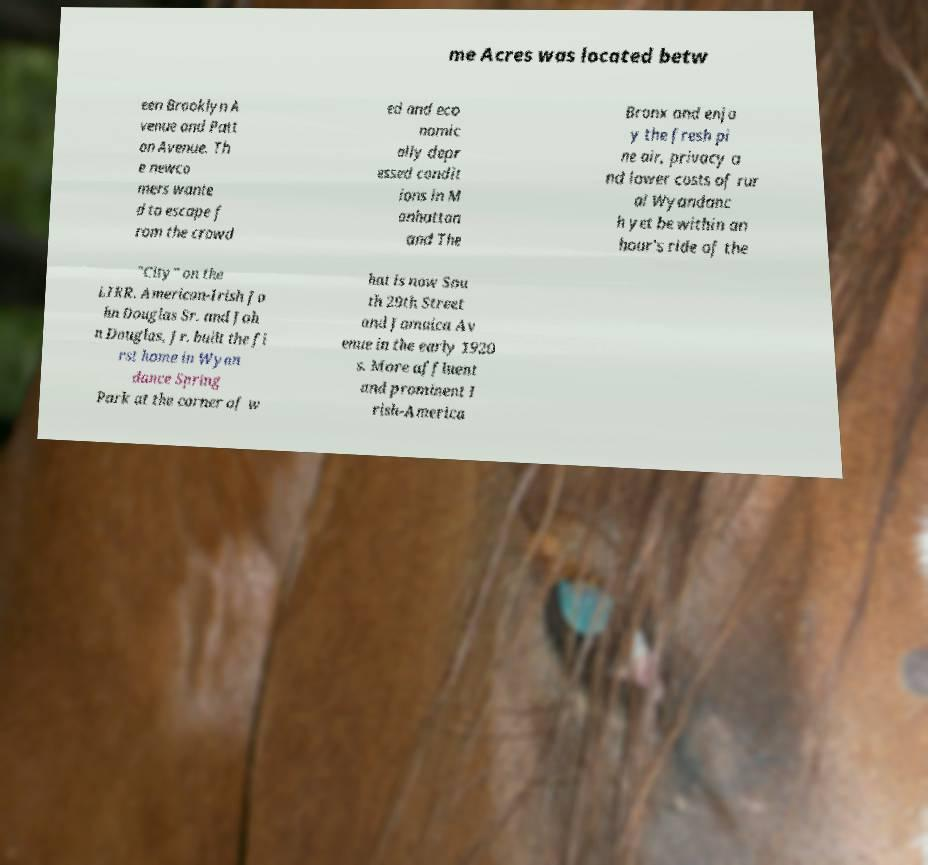What messages or text are displayed in this image? I need them in a readable, typed format. me Acres was located betw een Brooklyn A venue and Patt on Avenue. Th e newco mers wante d to escape f rom the crowd ed and eco nomic ally depr essed condit ions in M anhattan and The Bronx and enjo y the fresh pi ne air, privacy a nd lower costs of rur al Wyandanc h yet be within an hour's ride of the "City" on the LIRR. American-Irish Jo hn Douglas Sr. and Joh n Douglas, Jr. built the fi rst home in Wyan dance Spring Park at the corner of w hat is now Sou th 29th Street and Jamaica Av enue in the early 1920 s. More affluent and prominent I rish-America 